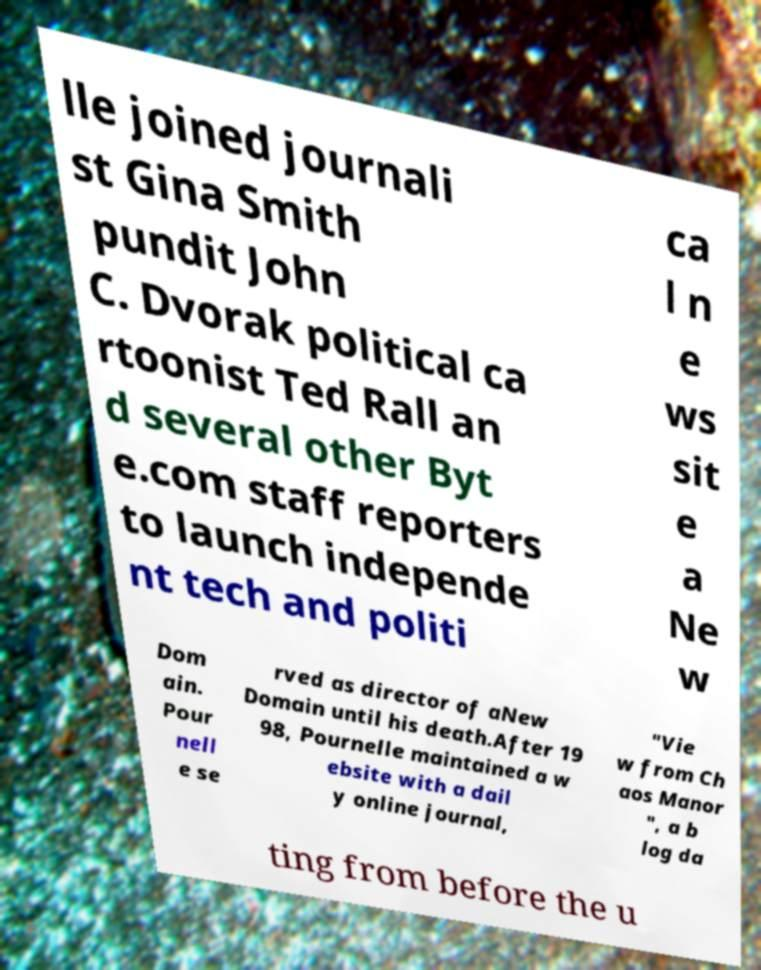What messages or text are displayed in this image? I need them in a readable, typed format. lle joined journali st Gina Smith pundit John C. Dvorak political ca rtoonist Ted Rall an d several other Byt e.com staff reporters to launch independe nt tech and politi ca l n e ws sit e a Ne w Dom ain. Pour nell e se rved as director of aNew Domain until his death.After 19 98, Pournelle maintained a w ebsite with a dail y online journal, "Vie w from Ch aos Manor ", a b log da ting from before the u 